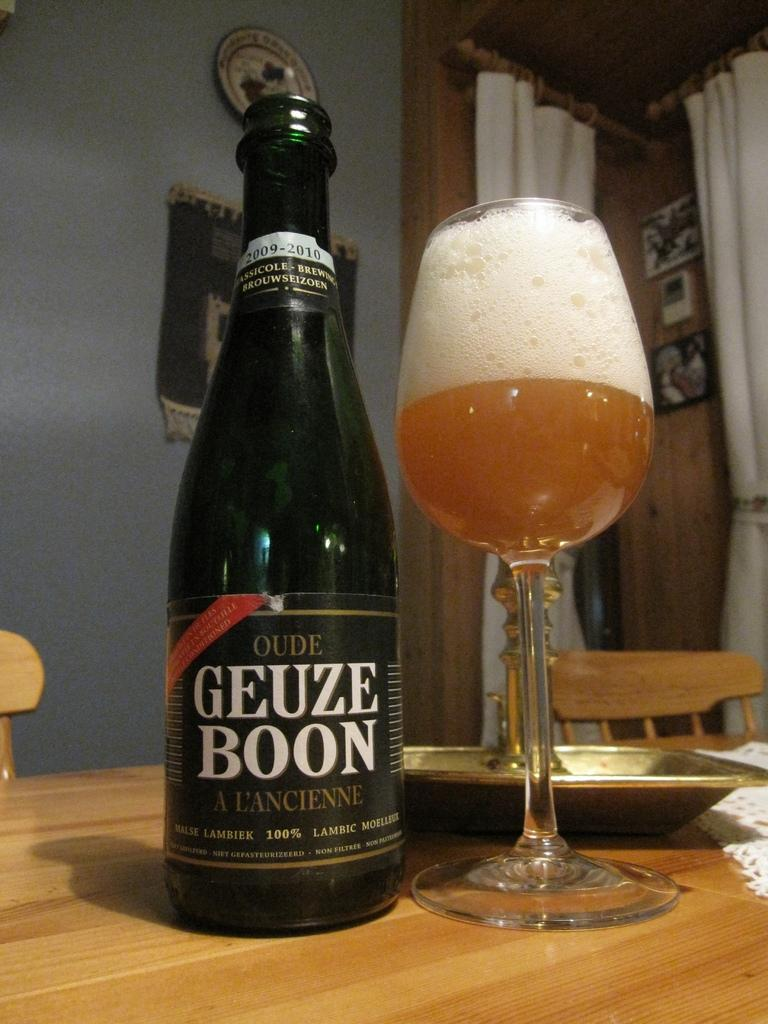<image>
Present a compact description of the photo's key features. A bottle of Geuze Boon beer sits next to a tall-stemmed glass. 